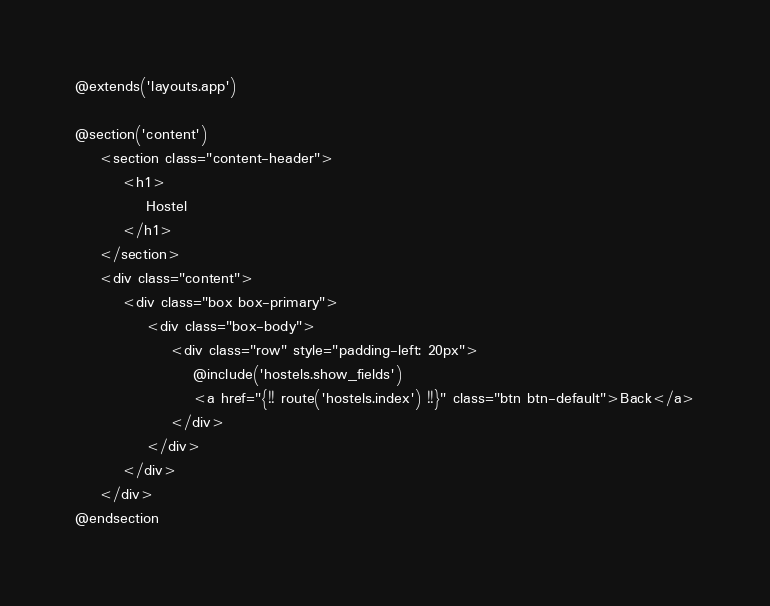<code> <loc_0><loc_0><loc_500><loc_500><_PHP_>@extends('layouts.app')

@section('content')
    <section class="content-header">
        <h1>
            Hostel
        </h1>
    </section>
    <div class="content">
        <div class="box box-primary">
            <div class="box-body">
                <div class="row" style="padding-left: 20px">
                    @include('hostels.show_fields')
                    <a href="{!! route('hostels.index') !!}" class="btn btn-default">Back</a>
                </div>
            </div>
        </div>
    </div>
@endsection
</code> 